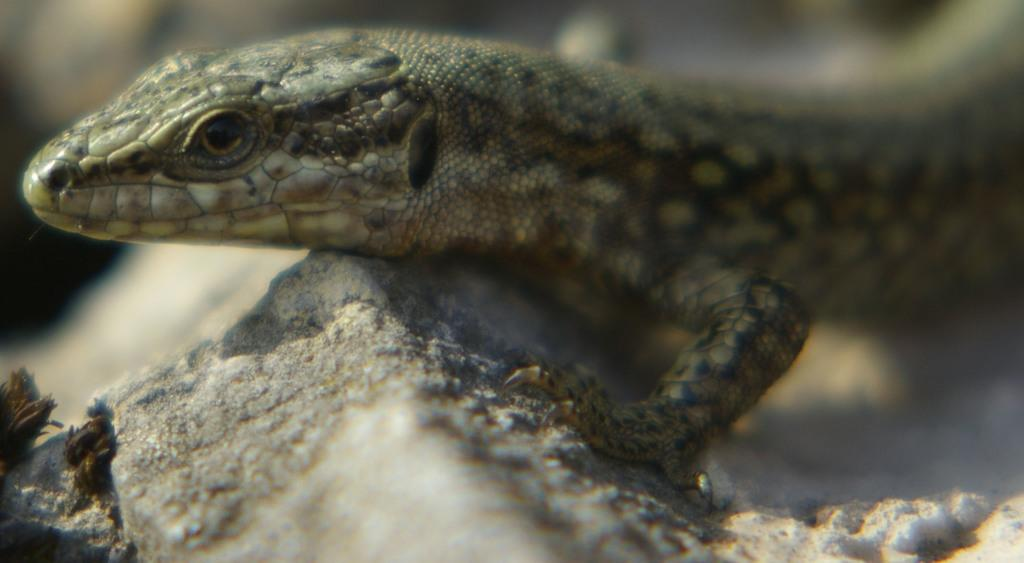What animal is present in the image? There is a lizard in the image. Where is the lizard located? The lizard is on a rock. Can you describe the background of the image? The background of the image is blurry. What type of chess piece is the lizard holding in the image? There is no chess piece present in the image, as it features a lizard on a rock with a blurry background. 